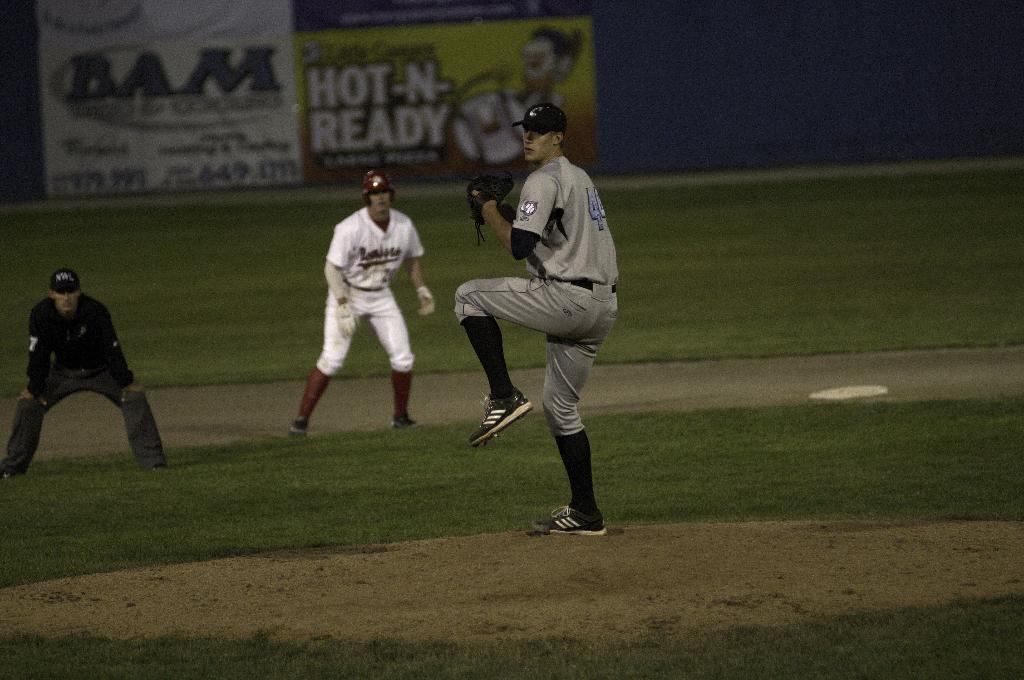What is hot-n-ready?
Your answer should be very brief. Unanswerable. 